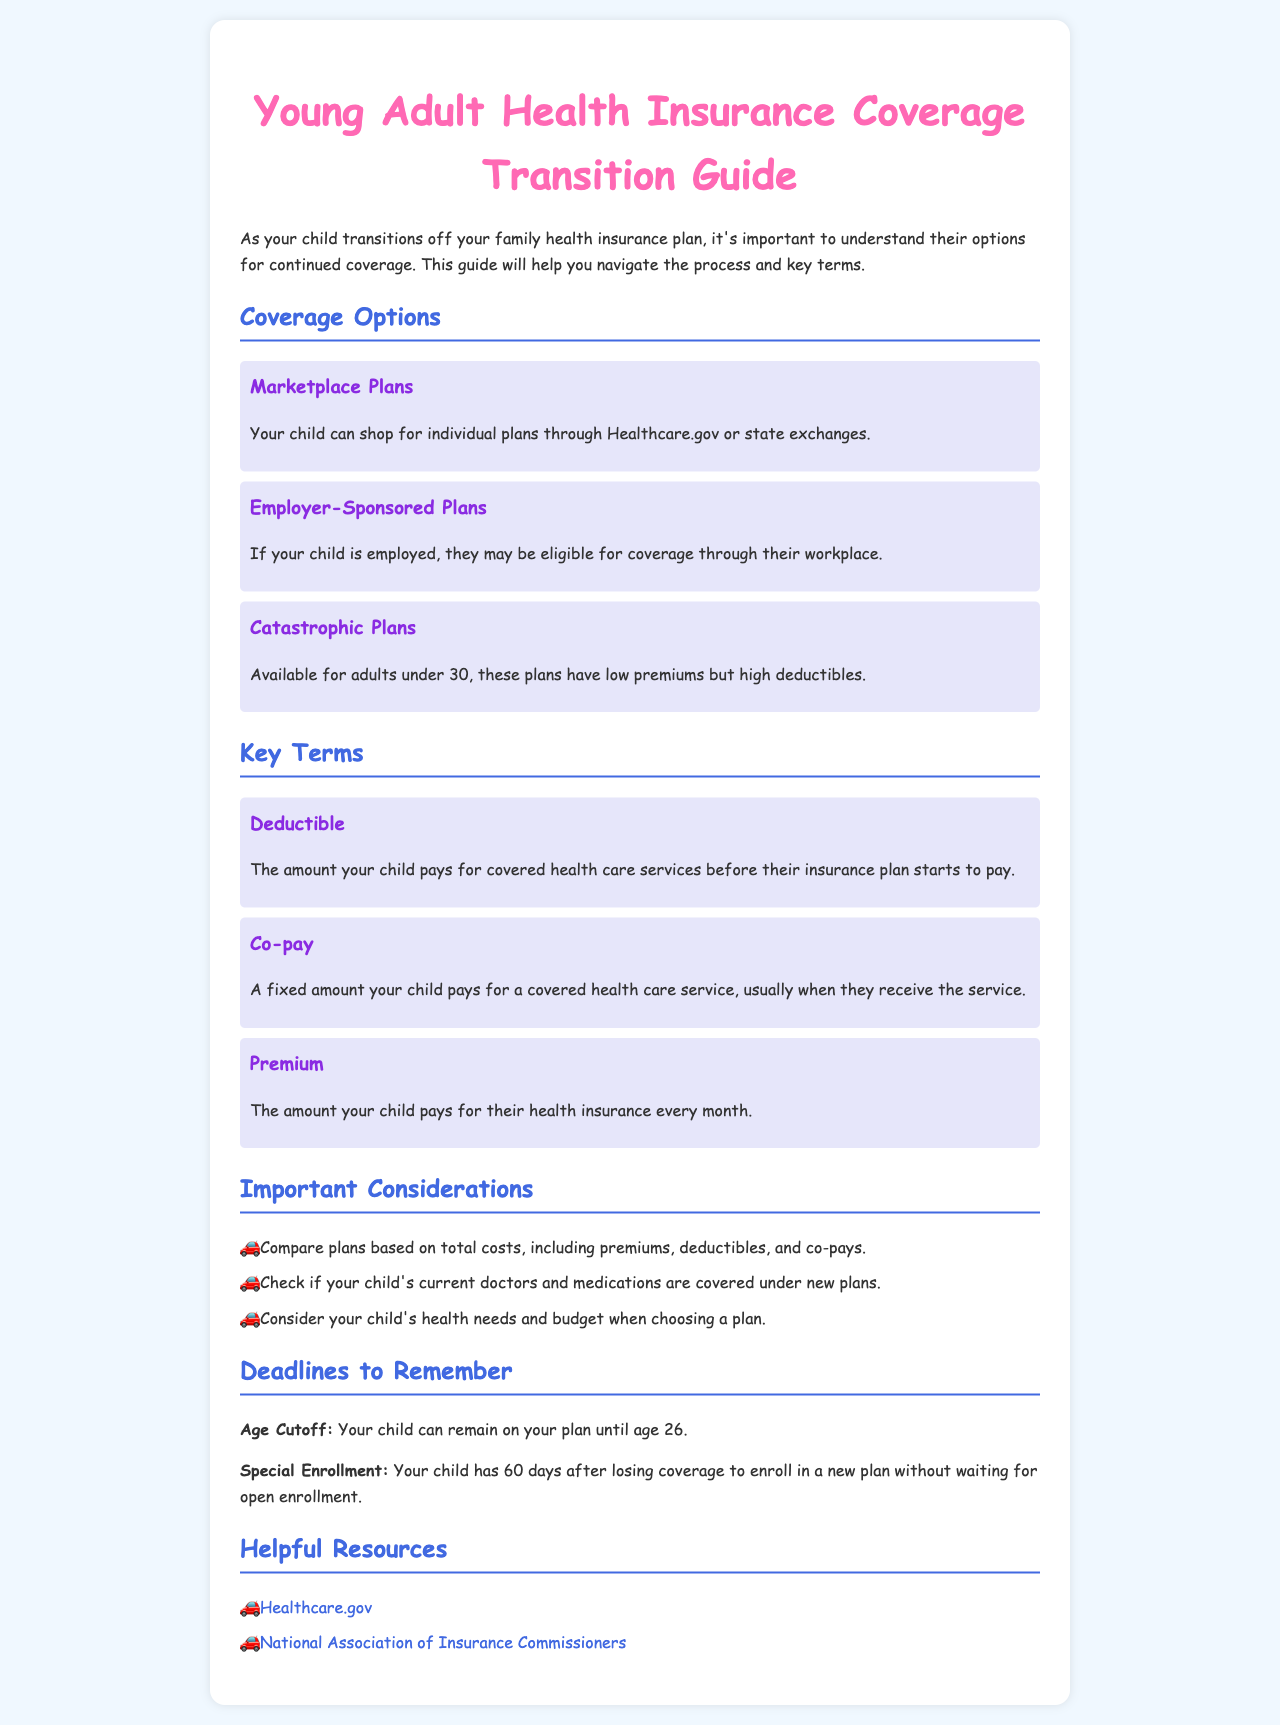what is the age cutoff for remaining on a parent's plan? The document states that your child can remain on your plan until age 26.
Answer: age 26 what is a co-pay? The document defines a co-pay as a fixed amount your child pays for a covered health care service, usually when they receive the service.
Answer: a fixed amount what type of plans are available for adults under 30? The document mentions that catastrophic plans are available for adults under 30.
Answer: catastrophic plans how long does your child have to enroll in a new plan after losing coverage? The document specifies that your child has 60 days after losing coverage to enroll in a new plan without waiting for open enrollment.
Answer: 60 days what should be considered when choosing a health plan? The document advises to consider your child's health needs and budget when choosing a plan.
Answer: health needs and budget what is the purpose of the Healthcare.gov link in the resources? The link to Healthcare.gov provides access to shop for individual plans through the marketplace.
Answer: shop for individual plans what is typically included in total costs to compare plans? The document notes that total costs include premiums, deductibles, and co-pays.
Answer: premiums, deductibles, and co-pays what does deductible mean? The document defines deductible as the amount your child pays for covered health care services before their insurance plan starts to pay.
Answer: amount before insurance pays 